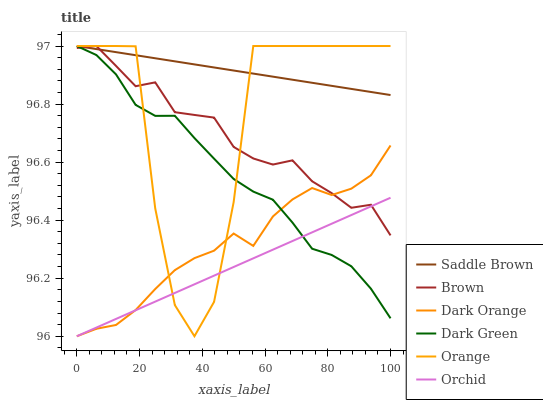Does Orchid have the minimum area under the curve?
Answer yes or no. Yes. Does Saddle Brown have the maximum area under the curve?
Answer yes or no. Yes. Does Dark Orange have the minimum area under the curve?
Answer yes or no. No. Does Dark Orange have the maximum area under the curve?
Answer yes or no. No. Is Orchid the smoothest?
Answer yes or no. Yes. Is Orange the roughest?
Answer yes or no. Yes. Is Dark Orange the smoothest?
Answer yes or no. No. Is Dark Orange the roughest?
Answer yes or no. No. Does Dark Orange have the lowest value?
Answer yes or no. Yes. Does Orange have the lowest value?
Answer yes or no. No. Does Dark Green have the highest value?
Answer yes or no. Yes. Does Dark Orange have the highest value?
Answer yes or no. No. Is Orchid less than Saddle Brown?
Answer yes or no. Yes. Is Saddle Brown greater than Orchid?
Answer yes or no. Yes. Does Orchid intersect Dark Green?
Answer yes or no. Yes. Is Orchid less than Dark Green?
Answer yes or no. No. Is Orchid greater than Dark Green?
Answer yes or no. No. Does Orchid intersect Saddle Brown?
Answer yes or no. No. 